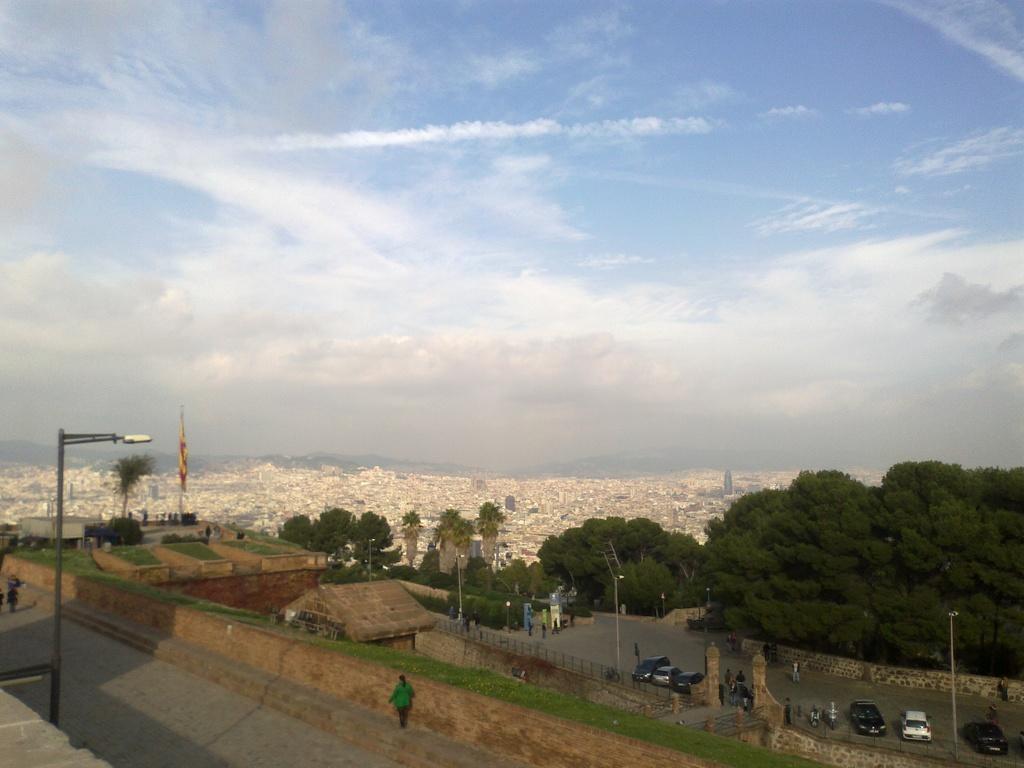Could you give a brief overview of what you see in this image? This is the picture of a city. In this image there are buildings and trees. In the foreground there is a flag and there are street lights and there are vehicles on the road and there are group of people on the road and there is a railing. At the top there is sky and there are clouds. At the bottom there is a road and there is grass. 